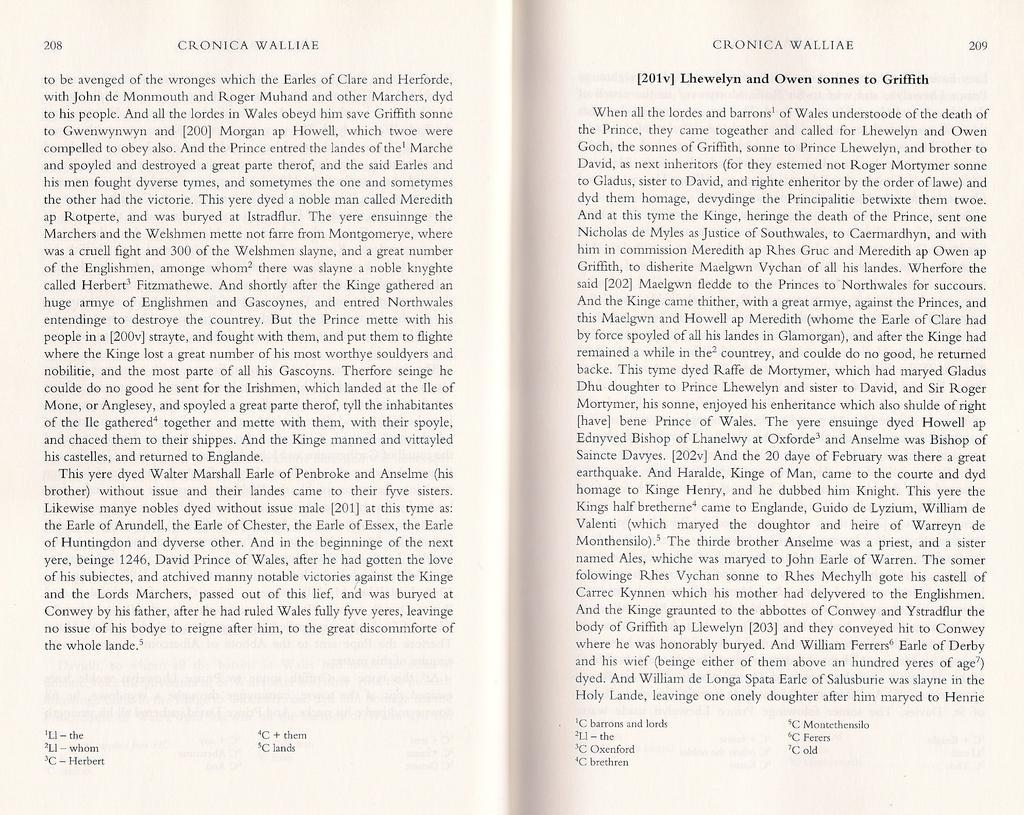How would you summarize this image in a sentence or two? In this picture we can see two pages where, we can see some text and page numbers on the pages. 